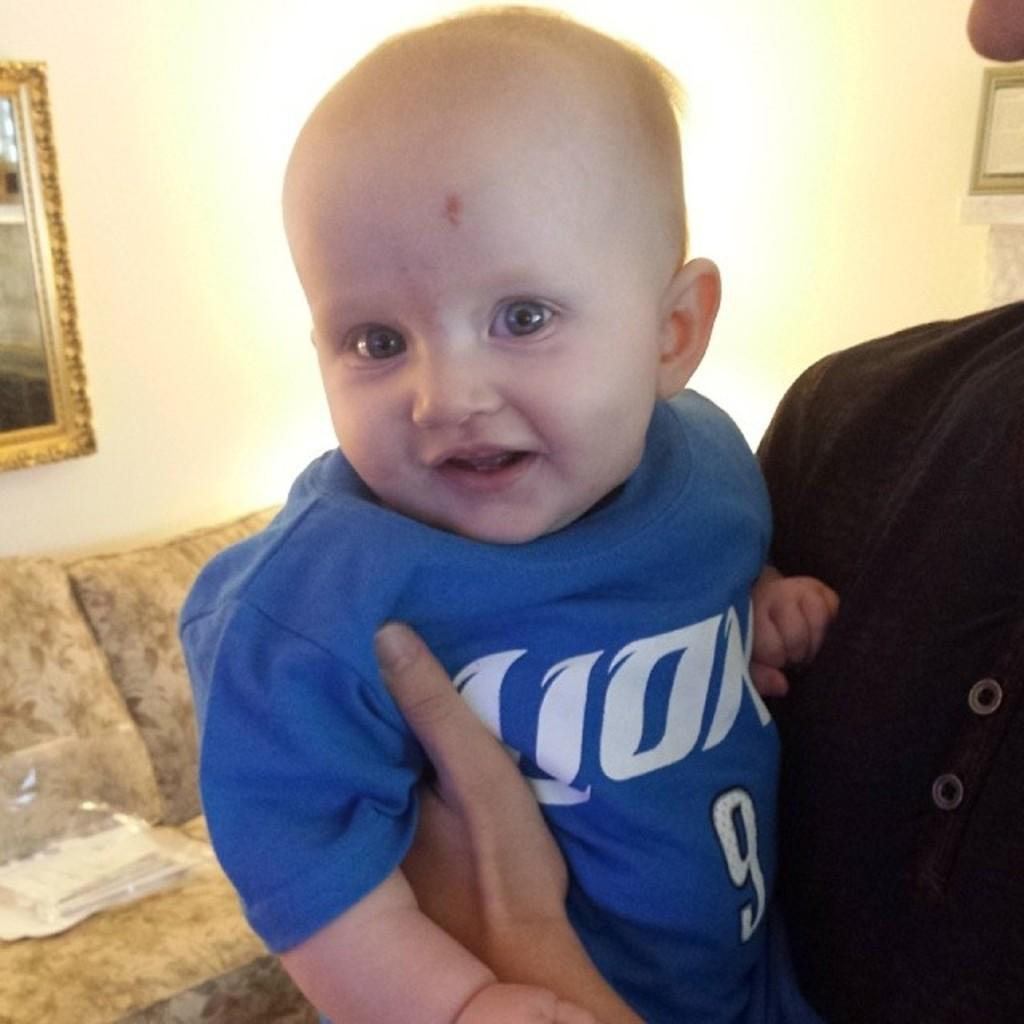<image>
Offer a succinct explanation of the picture presented. someone holding a baby in blue shirt with a 9 on it and a couch and picture behind them 